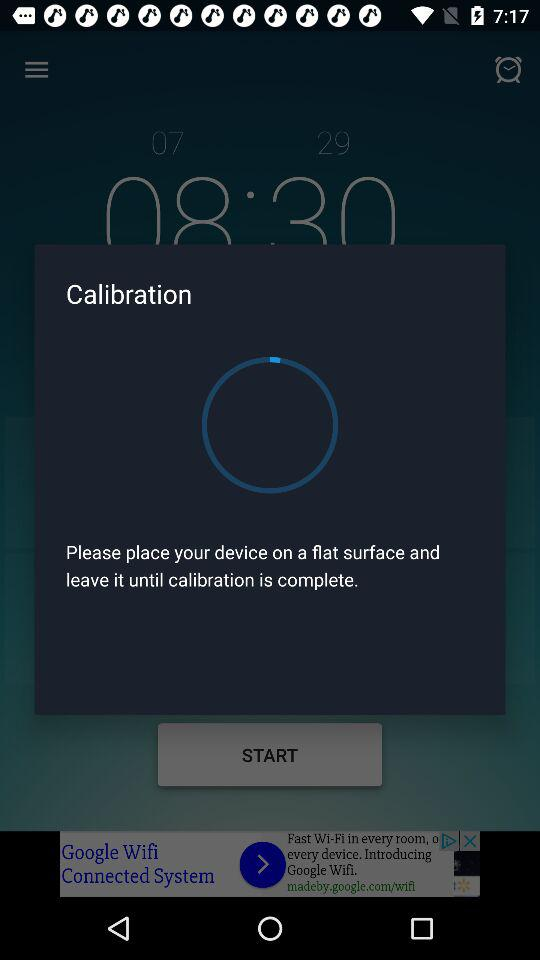How many hours of sleep did I get?
Answer the question using a single word or phrase. 7h 52min 